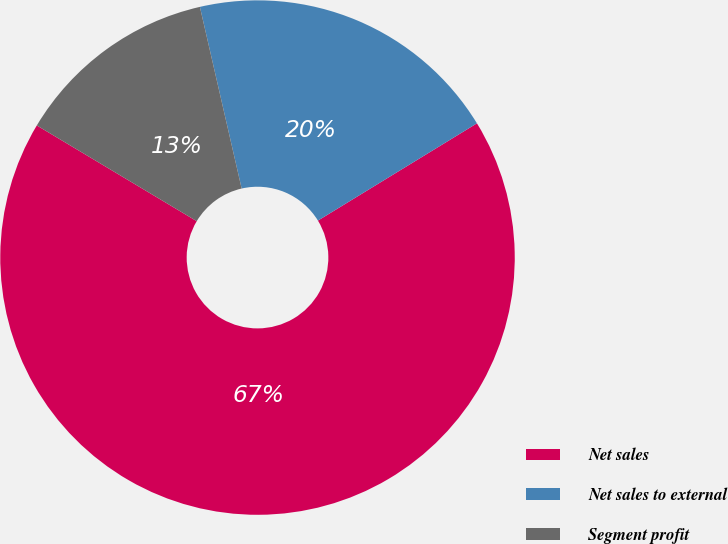Convert chart to OTSL. <chart><loc_0><loc_0><loc_500><loc_500><pie_chart><fcel>Net sales<fcel>Net sales to external<fcel>Segment profit<nl><fcel>67.33%<fcel>19.86%<fcel>12.82%<nl></chart> 